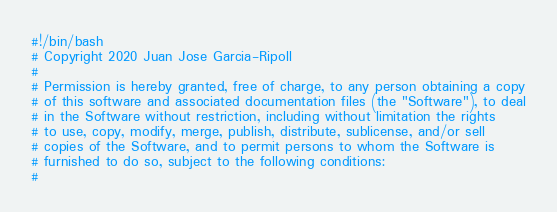Convert code to text. <code><loc_0><loc_0><loc_500><loc_500><_Bash_>#!/bin/bash
# Copyright 2020 Juan Jose Garcia-Ripoll
#
# Permission is hereby granted, free of charge, to any person obtaining a copy
# of this software and associated documentation files (the "Software"), to deal
# in the Software without restriction, including without limitation the rights
# to use, copy, modify, merge, publish, distribute, sublicense, and/or sell
# copies of the Software, and to permit persons to whom the Software is
# furnished to do so, subject to the following conditions:
#</code> 